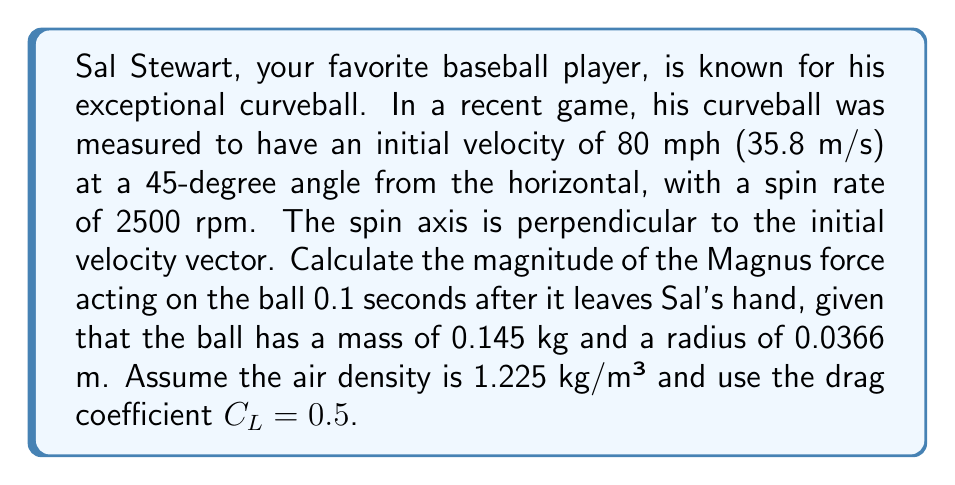Give your solution to this math problem. To solve this problem, we'll use vector calculus and the given spin rate data to analyze the pitch movement. Let's break it down step-by-step:

1. First, we need to calculate the angular velocity $\omega$ from the spin rate:
   $$\omega = 2\pi \cdot \frac{2500}{60} = 261.8 \text{ rad/s}$$

2. The Magnus force is given by the equation:
   $$\vec{F}_M = \frac{1}{2}\rho A C_L (\vec{\omega} \times \vec{v})$$
   where:
   - $\rho$ is the air density
   - $A$ is the cross-sectional area of the ball
   - $C_L$ is the lift coefficient
   - $\vec{\omega}$ is the angular velocity vector
   - $\vec{v}$ is the velocity vector

3. Calculate the cross-sectional area of the ball:
   $$A = \pi r^2 = \pi (0.0366)^2 = 0.00421 \text{ m}^2$$

4. The initial velocity components are:
   $$v_x = 35.8 \cos(45°) = 25.3 \text{ m/s}$$
   $$v_y = 35.8 \sin(45°) = 25.3 \text{ m/s}$$

5. After 0.1 seconds, neglecting air resistance, the velocity components are:
   $$v_x = 25.3 \text{ m/s}$$
   $$v_y = 25.3 - 9.8 \cdot 0.1 = 24.32 \text{ m/s}$$

6. The velocity vector at 0.1 seconds is:
   $$\vec{v} = 25.3\hat{i} + 24.32\hat{j} \text{ m/s}$$

7. The angular velocity vector is perpendicular to the initial velocity:
   $$\vec{\omega} = 261.8\hat{k} \text{ rad/s}$$

8. Calculate the cross product $\vec{\omega} \times \vec{v}$:
   $$\vec{\omega} \times \vec{v} = \begin{vmatrix} 
   \hat{i} & \hat{j} & \hat{k} \\
   0 & 0 & 261.8 \\
   25.3 & 24.32 & 0
   \end{vmatrix} = -6368.1\hat{i} + 6623.5\hat{j} \text{ m²/s²}$$

9. Now we can calculate the Magnus force:
   $$\vec{F}_M = \frac{1}{2} \cdot 1.225 \cdot 0.00421 \cdot 0.5 \cdot (-6368.1\hat{i} + 6623.5\hat{j})$$
   $$\vec{F}_M = -0.0082\hat{i} + 0.0085\hat{j} \text{ N}$$

10. The magnitude of the Magnus force is:
    $$|\vec{F}_M| = \sqrt{(-0.0082)^2 + (0.0085)^2} = 0.0118 \text{ N}$$
Answer: The magnitude of the Magnus force acting on Sal Stewart's curveball 0.1 seconds after it leaves his hand is 0.0118 N. 